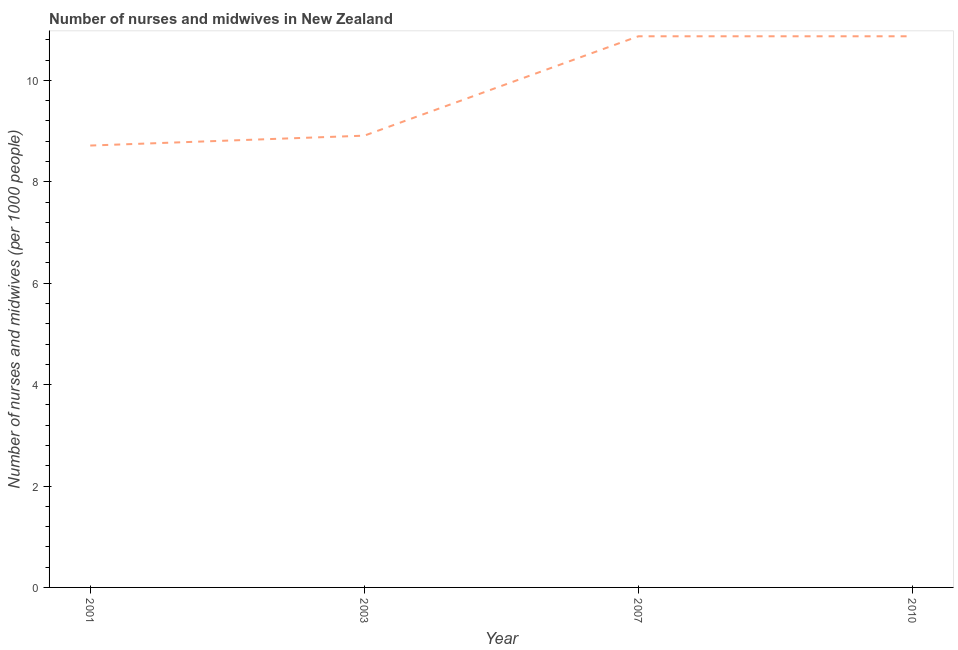What is the number of nurses and midwives in 2003?
Give a very brief answer. 8.91. Across all years, what is the maximum number of nurses and midwives?
Keep it short and to the point. 10.87. Across all years, what is the minimum number of nurses and midwives?
Offer a very short reply. 8.71. In which year was the number of nurses and midwives maximum?
Ensure brevity in your answer.  2007. In which year was the number of nurses and midwives minimum?
Your answer should be compact. 2001. What is the sum of the number of nurses and midwives?
Give a very brief answer. 39.36. What is the difference between the number of nurses and midwives in 2001 and 2003?
Make the answer very short. -0.2. What is the average number of nurses and midwives per year?
Your response must be concise. 9.84. What is the median number of nurses and midwives?
Keep it short and to the point. 9.89. In how many years, is the number of nurses and midwives greater than 5.2 ?
Make the answer very short. 4. What is the ratio of the number of nurses and midwives in 2003 to that in 2010?
Provide a short and direct response. 0.82. Is the difference between the number of nurses and midwives in 2003 and 2010 greater than the difference between any two years?
Your answer should be compact. No. What is the difference between the highest and the second highest number of nurses and midwives?
Your answer should be compact. 0. Is the sum of the number of nurses and midwives in 2003 and 2010 greater than the maximum number of nurses and midwives across all years?
Keep it short and to the point. Yes. What is the difference between the highest and the lowest number of nurses and midwives?
Your answer should be very brief. 2.15. How many lines are there?
Ensure brevity in your answer.  1. How many years are there in the graph?
Your answer should be very brief. 4. Does the graph contain any zero values?
Your response must be concise. No. Does the graph contain grids?
Your answer should be very brief. No. What is the title of the graph?
Your answer should be very brief. Number of nurses and midwives in New Zealand. What is the label or title of the Y-axis?
Your answer should be very brief. Number of nurses and midwives (per 1000 people). What is the Number of nurses and midwives (per 1000 people) of 2001?
Your answer should be compact. 8.71. What is the Number of nurses and midwives (per 1000 people) in 2003?
Your answer should be compact. 8.91. What is the Number of nurses and midwives (per 1000 people) in 2007?
Your response must be concise. 10.87. What is the Number of nurses and midwives (per 1000 people) of 2010?
Provide a short and direct response. 10.87. What is the difference between the Number of nurses and midwives (per 1000 people) in 2001 and 2003?
Ensure brevity in your answer.  -0.2. What is the difference between the Number of nurses and midwives (per 1000 people) in 2001 and 2007?
Ensure brevity in your answer.  -2.15. What is the difference between the Number of nurses and midwives (per 1000 people) in 2001 and 2010?
Your response must be concise. -2.15. What is the difference between the Number of nurses and midwives (per 1000 people) in 2003 and 2007?
Provide a succinct answer. -1.96. What is the difference between the Number of nurses and midwives (per 1000 people) in 2003 and 2010?
Make the answer very short. -1.96. What is the ratio of the Number of nurses and midwives (per 1000 people) in 2001 to that in 2007?
Your answer should be very brief. 0.8. What is the ratio of the Number of nurses and midwives (per 1000 people) in 2001 to that in 2010?
Give a very brief answer. 0.8. What is the ratio of the Number of nurses and midwives (per 1000 people) in 2003 to that in 2007?
Provide a short and direct response. 0.82. What is the ratio of the Number of nurses and midwives (per 1000 people) in 2003 to that in 2010?
Make the answer very short. 0.82. What is the ratio of the Number of nurses and midwives (per 1000 people) in 2007 to that in 2010?
Offer a terse response. 1. 